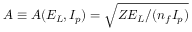Convert formula to latex. <formula><loc_0><loc_0><loc_500><loc_500>A \equiv A ( E _ { L } , I _ { p } ) = \sqrt { Z E _ { L } / ( n _ { f } { I _ { p } } ) }</formula> 